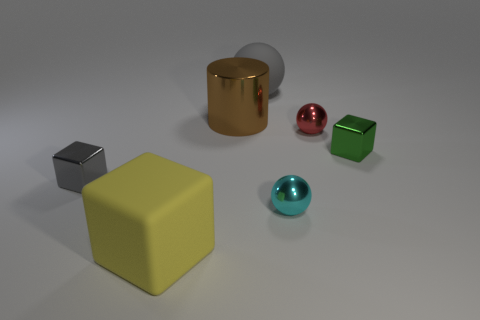The shiny object that is both on the left side of the small cyan metal object and in front of the large brown metallic object is what color?
Offer a terse response. Gray. There is a small sphere right of the cyan object; what is it made of?
Make the answer very short. Metal. How big is the yellow rubber block?
Your answer should be compact. Large. What number of gray objects are big matte objects or big matte spheres?
Provide a succinct answer. 1. There is a matte object on the left side of the sphere that is behind the brown shiny cylinder; how big is it?
Offer a terse response. Large. Does the large sphere have the same color as the small thing to the left of the matte sphere?
Your answer should be very brief. Yes. How many other things are the same material as the red sphere?
Your answer should be very brief. 4. What shape is the cyan thing that is made of the same material as the big brown cylinder?
Your response must be concise. Sphere. Is there anything else that has the same color as the large shiny object?
Keep it short and to the point. No. Are there more things on the left side of the large gray sphere than large cylinders?
Your response must be concise. Yes. 